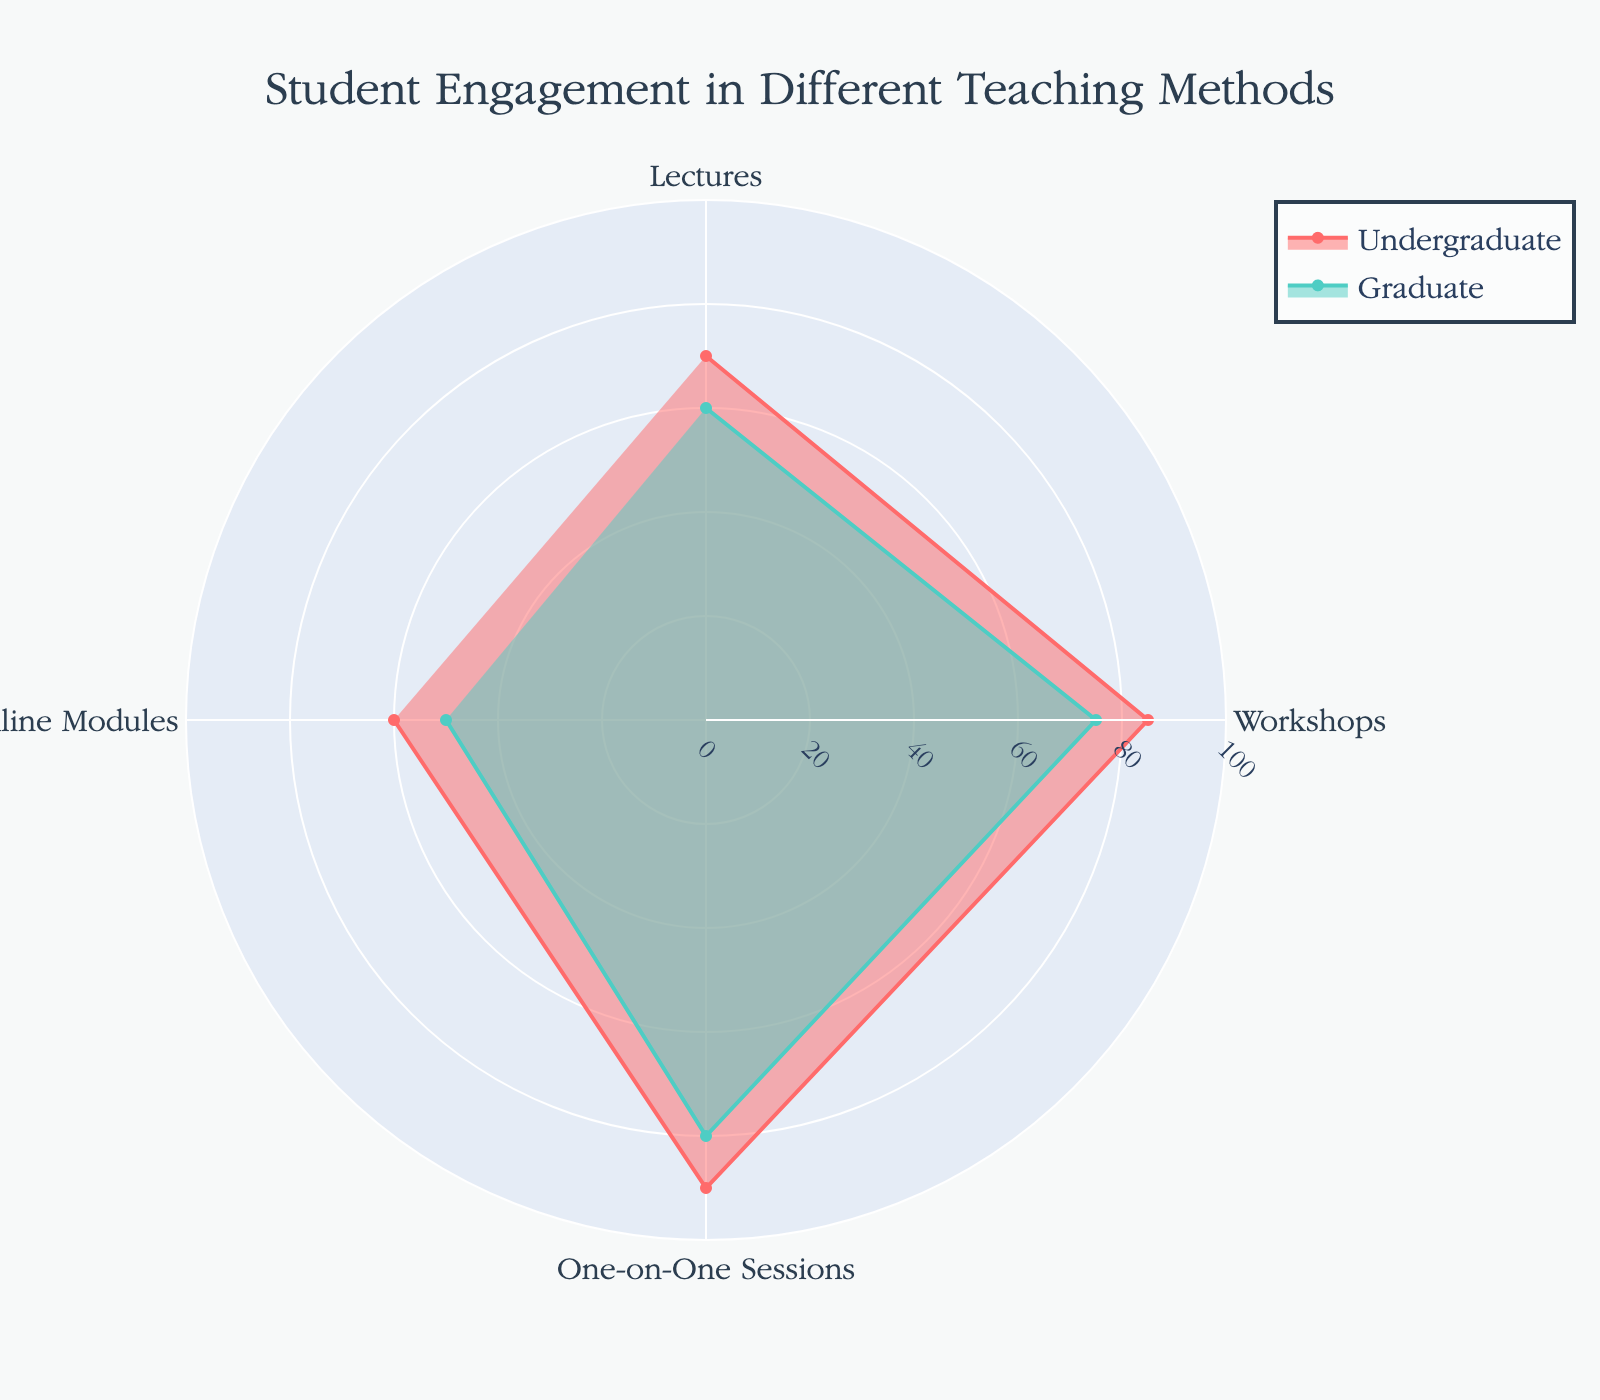How many teaching methods are represented in the radar chart? The radar chart shows four distinct categories corresponding to different teaching methods: "Lectures," "Workshops," "One-on-One Sessions," and "Online Modules."
Answer: Four What is the title of the radar chart? The title of the radar chart, displayed at the top center, reads "Student Engagement in Different Teaching Methods."
Answer: Student Engagement in Different Teaching Methods Which group shows the highest engagement for "Workshops"? To find the highest engagement for "Workshops," compare the values for Undergraduate and Graduate groups. The engagement levels are 85 for Undergraduates and 75 for Graduates, with Undergraduates showing the highest engagement.
Answer: Undergraduates What is the average engagement level for Graduates across all categories? Sum the engagement values for Graduates and divide by the number of categories: (60 + 75 + 80 + 50) / 4 = 265 / 4
Answer: 66.25 Compare the engagement levels between "Lectures" and "Online Modules" for Undergraduates. Which category has higher engagement and by how much? For Undergraduates, the engagement level for "Lectures" is 70 and for "Online Modules" is 60. Subtract 60 from 70 to find the difference.
Answer: Lectures by 10 points In which category is the difference between Undergraduate and Graduate engagement levels the smallest? Calculate the differences for each category:
- Lectures: 70 - 60 = 10
- Workshops: 85 - 75 = 10
- One-on-One Sessions: 90 - 80 = 10
- Online Modules: 60 - 50 = 10
All differences are equal (10 points)
Answer: All categories equal (10 points) What is the range of engagement levels for PhD students? The range is the difference between the highest and lowest values in the PhD group across all categories. 
- Highest: One-on-One Sessions (70)
- Lowest: Online Modules (45)
Range: 70 - 45
Answer: 25 Which teaching method shows the least engagement for Undergraduate students? Compare all engagement values for Undergraduate students across the categories. The lowest value is for "Online Modules" (60).
Answer: Online Modules What is the overall trend in engagement levels for "One-on-One Sessions" across all groups? Observe engagement levels across Undergraduate (90), Graduate (80), and PhD students (70). The levels decrease consistently from Undergraduate to PhD.
Answer: Decreasing trend Is the engagement level for Graduate students higher in "Lectures" or "Online Modules"? Compare the engagement levels for Graduate students in "Lectures" (60) and "Online Modules" (50). "Lectures" has a higher engagement level.
Answer: Lectures 